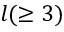<formula> <loc_0><loc_0><loc_500><loc_500>l ( \geq 3 )</formula> 